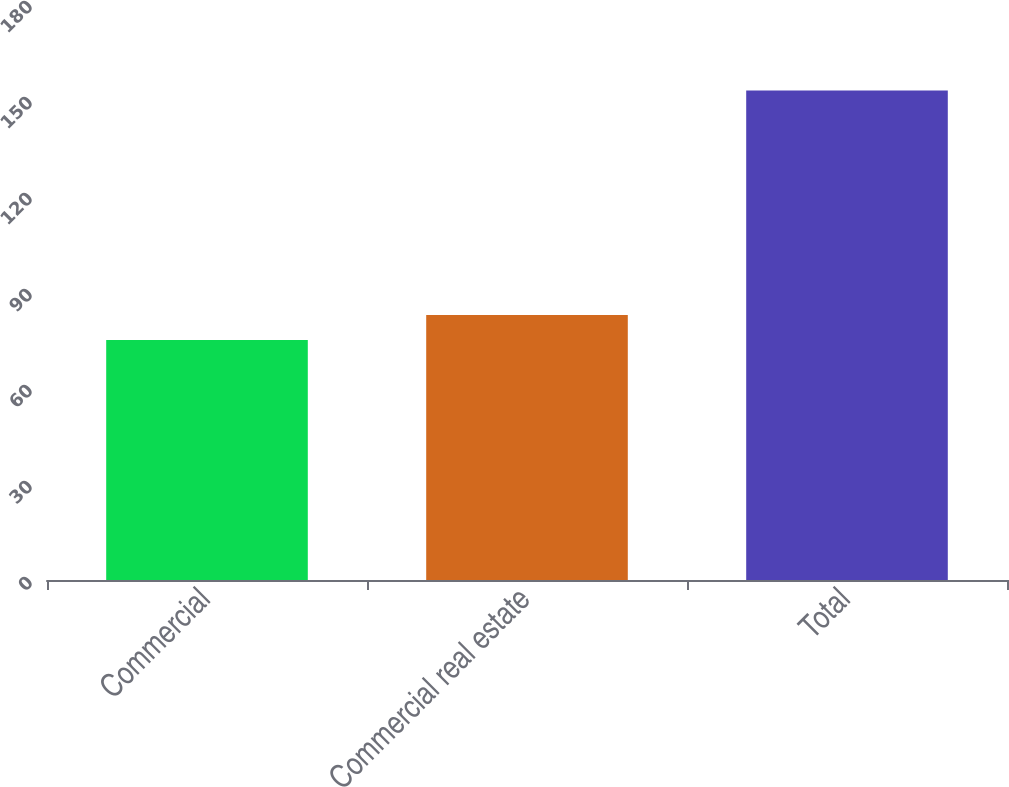Convert chart. <chart><loc_0><loc_0><loc_500><loc_500><bar_chart><fcel>Commercial<fcel>Commercial real estate<fcel>Total<nl><fcel>75<fcel>82.8<fcel>153<nl></chart> 